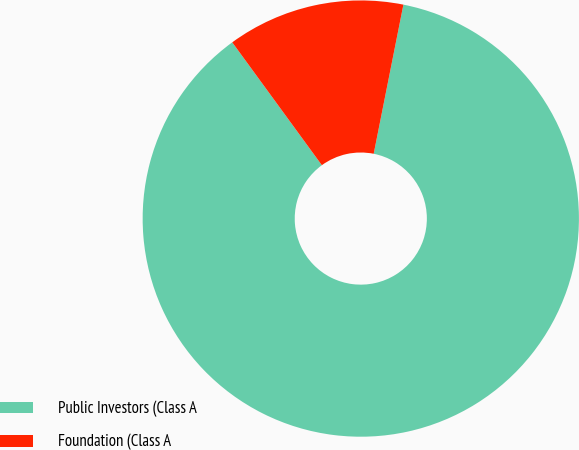<chart> <loc_0><loc_0><loc_500><loc_500><pie_chart><fcel>Public Investors (Class A<fcel>Foundation (Class A<nl><fcel>86.84%<fcel>13.16%<nl></chart> 